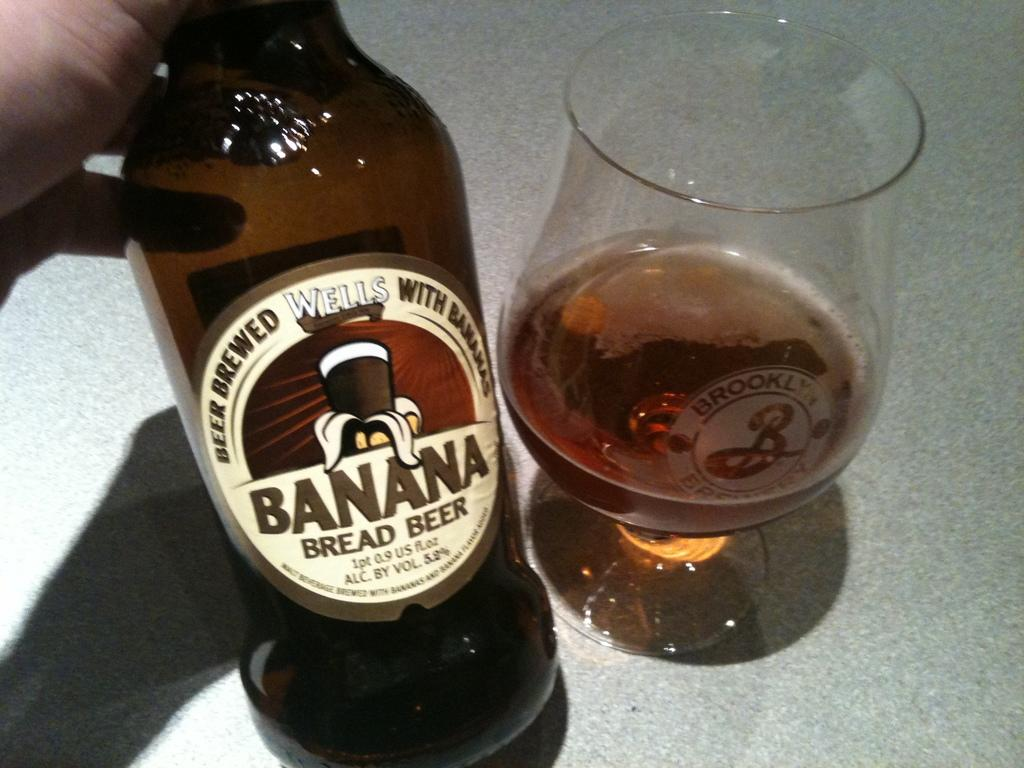<image>
Render a clear and concise summary of the photo. Banana Bread Beer that is Brewed from Wells and Bananas. 